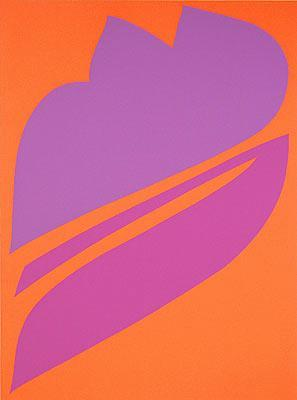If this abstract artwork were used in a modern city setting, how could it enhance public spaces? In a modern city setting, this abstract artwork could be used as a stunning mural on the side of a building, transforming a mundane wall into a vibrant and engaging piece of the urban landscape. The bold colors and striking design would serve as a focal point, drawing attention and invigorating the space. Alternatively, it could be displayed as a large installation in a public park, adding an element of contemporary art to the green space and providing a visual contrast to the natural surroundings, thereby enhancing the aesthetic appeal of the area. 